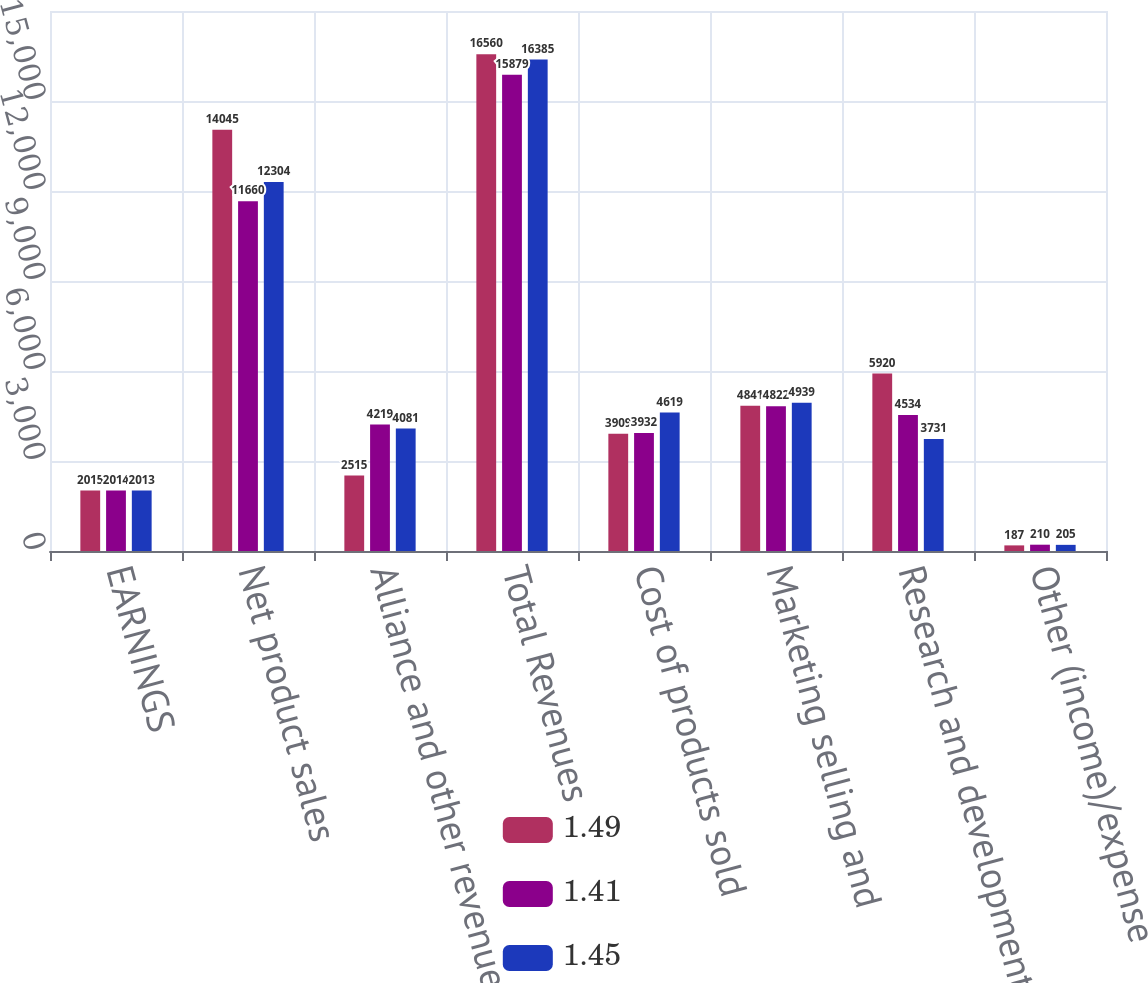Convert chart. <chart><loc_0><loc_0><loc_500><loc_500><stacked_bar_chart><ecel><fcel>EARNINGS<fcel>Net product sales<fcel>Alliance and other revenues<fcel>Total Revenues<fcel>Cost of products sold<fcel>Marketing selling and<fcel>Research and development<fcel>Other (income)/expense<nl><fcel>1.49<fcel>2015<fcel>14045<fcel>2515<fcel>16560<fcel>3909<fcel>4841<fcel>5920<fcel>187<nl><fcel>1.41<fcel>2014<fcel>11660<fcel>4219<fcel>15879<fcel>3932<fcel>4822<fcel>4534<fcel>210<nl><fcel>1.45<fcel>2013<fcel>12304<fcel>4081<fcel>16385<fcel>4619<fcel>4939<fcel>3731<fcel>205<nl></chart> 